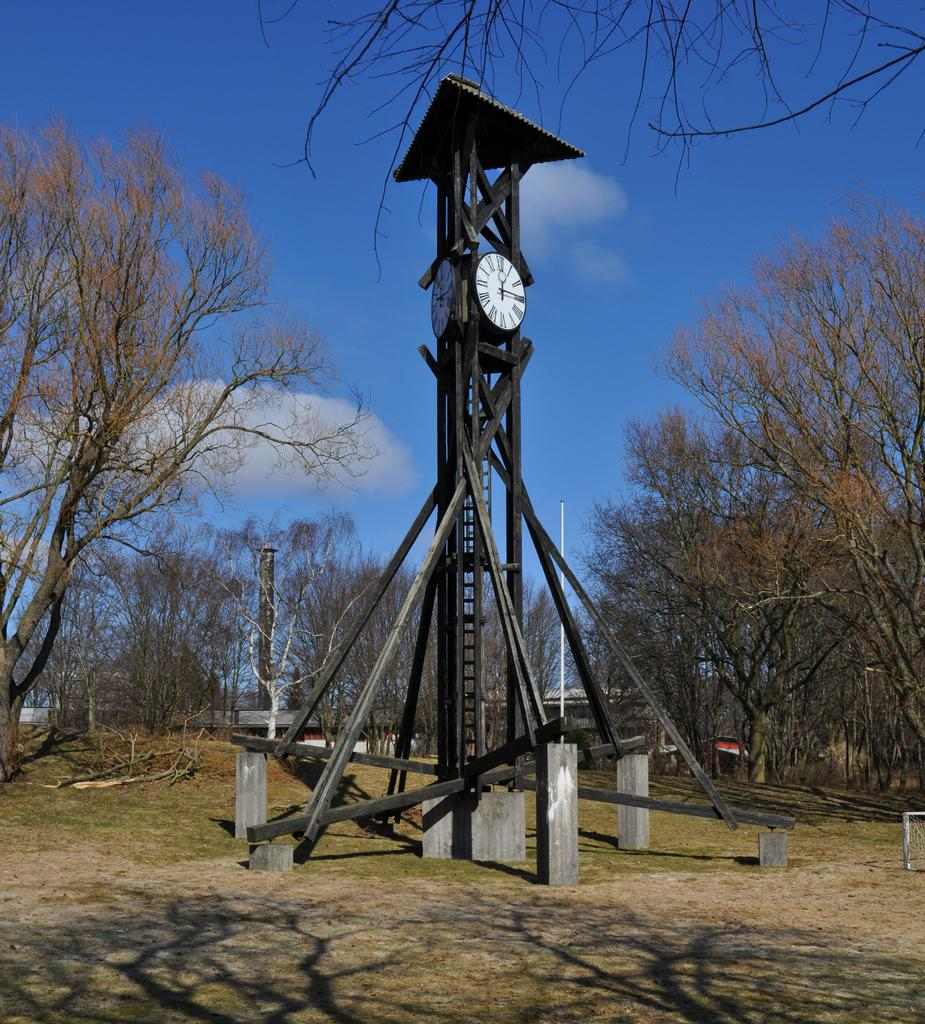What is the main structure in the image? There is a clock tower at the center of the image. What can be seen in the background of the image? There are trees and the sky visible in the background of the image. How many dinosaurs are climbing the clock tower in the image? There are no dinosaurs present in the image, and therefore none are climbing the clock tower. 